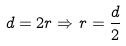Convert formula to latex. <formula><loc_0><loc_0><loc_500><loc_500>d = 2 r \Rightarrow r = \frac { d } { 2 }</formula> 